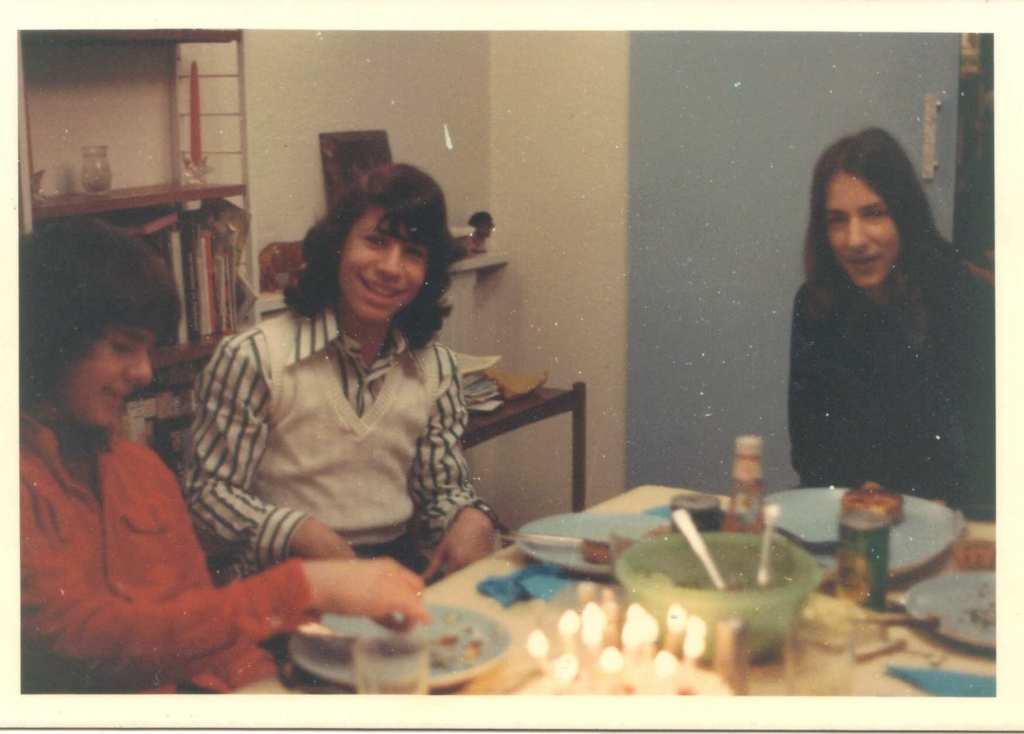Please provide a concise description of this image. In this image there are so many girls sitting around the table on which there is food served in bowls, behind them there is a shelf with so many books. 